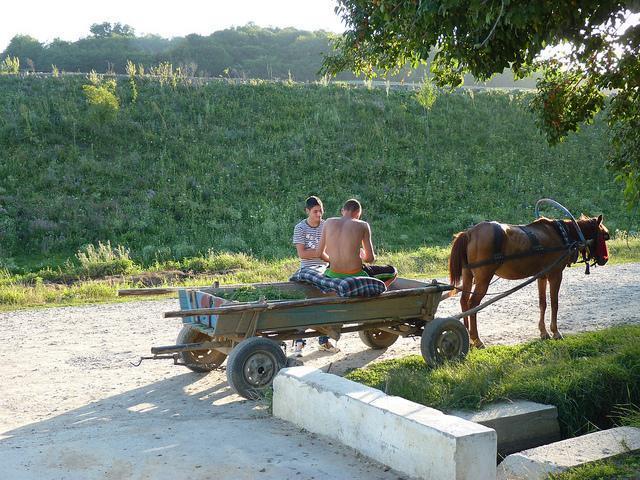How many horses are present?
Give a very brief answer. 1. How many giraffes are there?
Give a very brief answer. 0. 